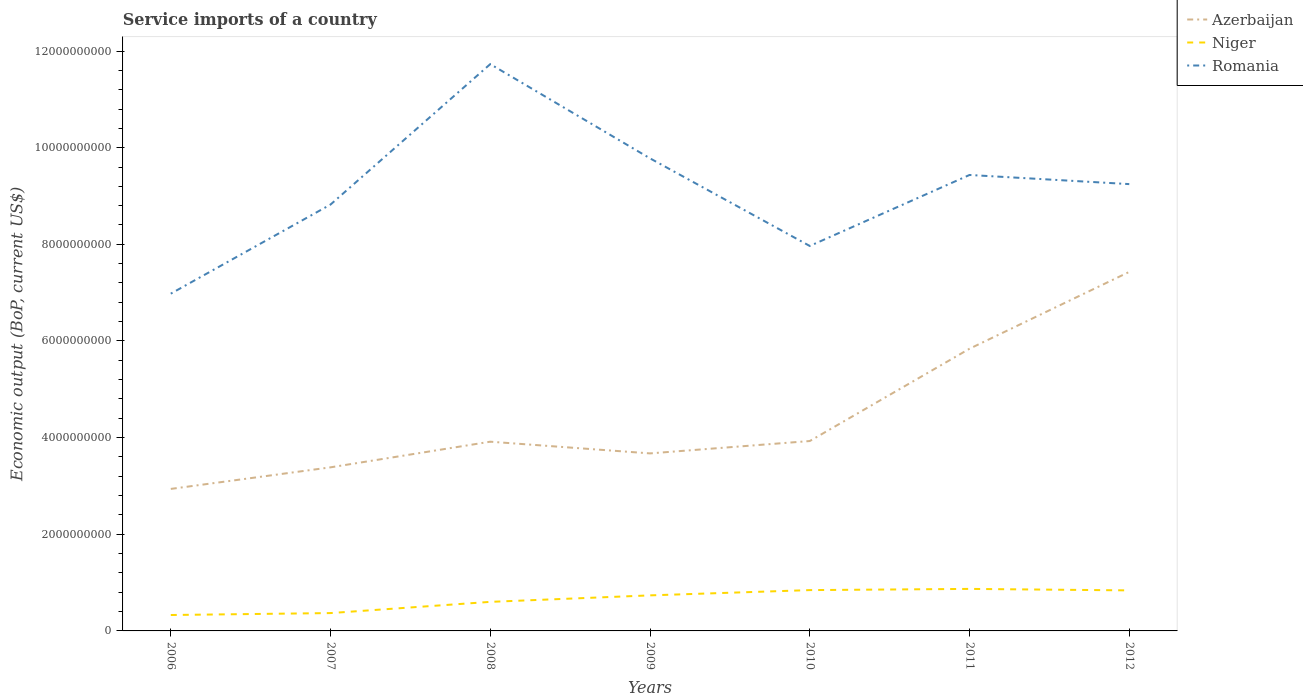How many different coloured lines are there?
Ensure brevity in your answer.  3. Is the number of lines equal to the number of legend labels?
Your answer should be very brief. Yes. Across all years, what is the maximum service imports in Romania?
Provide a short and direct response. 6.98e+09. What is the total service imports in Niger in the graph?
Offer a terse response. -1.34e+08. What is the difference between the highest and the second highest service imports in Niger?
Offer a very short reply. 5.40e+08. What is the difference between the highest and the lowest service imports in Azerbaijan?
Your answer should be very brief. 2. Is the service imports in Romania strictly greater than the service imports in Niger over the years?
Keep it short and to the point. No. How many lines are there?
Your answer should be very brief. 3. Are the values on the major ticks of Y-axis written in scientific E-notation?
Your response must be concise. No. How many legend labels are there?
Your answer should be very brief. 3. What is the title of the graph?
Offer a terse response. Service imports of a country. Does "Kenya" appear as one of the legend labels in the graph?
Your response must be concise. No. What is the label or title of the X-axis?
Provide a succinct answer. Years. What is the label or title of the Y-axis?
Your answer should be compact. Economic output (BoP, current US$). What is the Economic output (BoP, current US$) in Azerbaijan in 2006?
Your answer should be very brief. 2.94e+09. What is the Economic output (BoP, current US$) in Niger in 2006?
Make the answer very short. 3.29e+08. What is the Economic output (BoP, current US$) in Romania in 2006?
Your response must be concise. 6.98e+09. What is the Economic output (BoP, current US$) of Azerbaijan in 2007?
Offer a very short reply. 3.39e+09. What is the Economic output (BoP, current US$) of Niger in 2007?
Your response must be concise. 3.69e+08. What is the Economic output (BoP, current US$) of Romania in 2007?
Ensure brevity in your answer.  8.82e+09. What is the Economic output (BoP, current US$) in Azerbaijan in 2008?
Provide a short and direct response. 3.92e+09. What is the Economic output (BoP, current US$) of Niger in 2008?
Ensure brevity in your answer.  6.01e+08. What is the Economic output (BoP, current US$) of Romania in 2008?
Your response must be concise. 1.17e+1. What is the Economic output (BoP, current US$) in Azerbaijan in 2009?
Keep it short and to the point. 3.67e+09. What is the Economic output (BoP, current US$) of Niger in 2009?
Provide a short and direct response. 7.36e+08. What is the Economic output (BoP, current US$) in Romania in 2009?
Your answer should be compact. 9.78e+09. What is the Economic output (BoP, current US$) in Azerbaijan in 2010?
Ensure brevity in your answer.  3.93e+09. What is the Economic output (BoP, current US$) in Niger in 2010?
Give a very brief answer. 8.45e+08. What is the Economic output (BoP, current US$) of Romania in 2010?
Provide a succinct answer. 7.97e+09. What is the Economic output (BoP, current US$) of Azerbaijan in 2011?
Keep it short and to the point. 5.84e+09. What is the Economic output (BoP, current US$) of Niger in 2011?
Provide a succinct answer. 8.70e+08. What is the Economic output (BoP, current US$) of Romania in 2011?
Offer a very short reply. 9.44e+09. What is the Economic output (BoP, current US$) in Azerbaijan in 2012?
Provide a short and direct response. 7.43e+09. What is the Economic output (BoP, current US$) of Niger in 2012?
Keep it short and to the point. 8.39e+08. What is the Economic output (BoP, current US$) in Romania in 2012?
Give a very brief answer. 9.25e+09. Across all years, what is the maximum Economic output (BoP, current US$) in Azerbaijan?
Make the answer very short. 7.43e+09. Across all years, what is the maximum Economic output (BoP, current US$) in Niger?
Your answer should be very brief. 8.70e+08. Across all years, what is the maximum Economic output (BoP, current US$) of Romania?
Make the answer very short. 1.17e+1. Across all years, what is the minimum Economic output (BoP, current US$) in Azerbaijan?
Give a very brief answer. 2.94e+09. Across all years, what is the minimum Economic output (BoP, current US$) of Niger?
Ensure brevity in your answer.  3.29e+08. Across all years, what is the minimum Economic output (BoP, current US$) in Romania?
Your answer should be very brief. 6.98e+09. What is the total Economic output (BoP, current US$) of Azerbaijan in the graph?
Make the answer very short. 3.11e+1. What is the total Economic output (BoP, current US$) in Niger in the graph?
Offer a terse response. 4.59e+09. What is the total Economic output (BoP, current US$) of Romania in the graph?
Your answer should be very brief. 6.40e+1. What is the difference between the Economic output (BoP, current US$) in Azerbaijan in 2006 and that in 2007?
Keep it short and to the point. -4.47e+08. What is the difference between the Economic output (BoP, current US$) of Niger in 2006 and that in 2007?
Provide a succinct answer. -4.00e+07. What is the difference between the Economic output (BoP, current US$) in Romania in 2006 and that in 2007?
Your response must be concise. -1.84e+09. What is the difference between the Economic output (BoP, current US$) of Azerbaijan in 2006 and that in 2008?
Offer a very short reply. -9.77e+08. What is the difference between the Economic output (BoP, current US$) of Niger in 2006 and that in 2008?
Provide a short and direct response. -2.72e+08. What is the difference between the Economic output (BoP, current US$) in Romania in 2006 and that in 2008?
Your answer should be very brief. -4.75e+09. What is the difference between the Economic output (BoP, current US$) in Azerbaijan in 2006 and that in 2009?
Your response must be concise. -7.35e+08. What is the difference between the Economic output (BoP, current US$) of Niger in 2006 and that in 2009?
Keep it short and to the point. -4.06e+08. What is the difference between the Economic output (BoP, current US$) in Romania in 2006 and that in 2009?
Provide a succinct answer. -2.80e+09. What is the difference between the Economic output (BoP, current US$) in Azerbaijan in 2006 and that in 2010?
Give a very brief answer. -9.91e+08. What is the difference between the Economic output (BoP, current US$) in Niger in 2006 and that in 2010?
Provide a succinct answer. -5.15e+08. What is the difference between the Economic output (BoP, current US$) of Romania in 2006 and that in 2010?
Ensure brevity in your answer.  -9.87e+08. What is the difference between the Economic output (BoP, current US$) in Azerbaijan in 2006 and that in 2011?
Your answer should be compact. -2.90e+09. What is the difference between the Economic output (BoP, current US$) in Niger in 2006 and that in 2011?
Keep it short and to the point. -5.40e+08. What is the difference between the Economic output (BoP, current US$) in Romania in 2006 and that in 2011?
Provide a succinct answer. -2.46e+09. What is the difference between the Economic output (BoP, current US$) of Azerbaijan in 2006 and that in 2012?
Your answer should be very brief. -4.49e+09. What is the difference between the Economic output (BoP, current US$) of Niger in 2006 and that in 2012?
Offer a very short reply. -5.09e+08. What is the difference between the Economic output (BoP, current US$) in Romania in 2006 and that in 2012?
Offer a terse response. -2.27e+09. What is the difference between the Economic output (BoP, current US$) of Azerbaijan in 2007 and that in 2008?
Offer a terse response. -5.30e+08. What is the difference between the Economic output (BoP, current US$) in Niger in 2007 and that in 2008?
Make the answer very short. -2.32e+08. What is the difference between the Economic output (BoP, current US$) in Romania in 2007 and that in 2008?
Offer a terse response. -2.91e+09. What is the difference between the Economic output (BoP, current US$) in Azerbaijan in 2007 and that in 2009?
Make the answer very short. -2.88e+08. What is the difference between the Economic output (BoP, current US$) of Niger in 2007 and that in 2009?
Provide a short and direct response. -3.66e+08. What is the difference between the Economic output (BoP, current US$) in Romania in 2007 and that in 2009?
Keep it short and to the point. -9.56e+08. What is the difference between the Economic output (BoP, current US$) of Azerbaijan in 2007 and that in 2010?
Provide a succinct answer. -5.44e+08. What is the difference between the Economic output (BoP, current US$) in Niger in 2007 and that in 2010?
Provide a short and direct response. -4.75e+08. What is the difference between the Economic output (BoP, current US$) of Romania in 2007 and that in 2010?
Offer a terse response. 8.57e+08. What is the difference between the Economic output (BoP, current US$) of Azerbaijan in 2007 and that in 2011?
Your answer should be very brief. -2.45e+09. What is the difference between the Economic output (BoP, current US$) of Niger in 2007 and that in 2011?
Give a very brief answer. -5.00e+08. What is the difference between the Economic output (BoP, current US$) of Romania in 2007 and that in 2011?
Make the answer very short. -6.12e+08. What is the difference between the Economic output (BoP, current US$) of Azerbaijan in 2007 and that in 2012?
Give a very brief answer. -4.04e+09. What is the difference between the Economic output (BoP, current US$) in Niger in 2007 and that in 2012?
Provide a short and direct response. -4.69e+08. What is the difference between the Economic output (BoP, current US$) of Romania in 2007 and that in 2012?
Ensure brevity in your answer.  -4.23e+08. What is the difference between the Economic output (BoP, current US$) in Azerbaijan in 2008 and that in 2009?
Make the answer very short. 2.42e+08. What is the difference between the Economic output (BoP, current US$) in Niger in 2008 and that in 2009?
Provide a short and direct response. -1.34e+08. What is the difference between the Economic output (BoP, current US$) in Romania in 2008 and that in 2009?
Give a very brief answer. 1.95e+09. What is the difference between the Economic output (BoP, current US$) in Azerbaijan in 2008 and that in 2010?
Your answer should be compact. -1.38e+07. What is the difference between the Economic output (BoP, current US$) in Niger in 2008 and that in 2010?
Ensure brevity in your answer.  -2.43e+08. What is the difference between the Economic output (BoP, current US$) in Romania in 2008 and that in 2010?
Keep it short and to the point. 3.76e+09. What is the difference between the Economic output (BoP, current US$) in Azerbaijan in 2008 and that in 2011?
Ensure brevity in your answer.  -1.92e+09. What is the difference between the Economic output (BoP, current US$) of Niger in 2008 and that in 2011?
Keep it short and to the point. -2.68e+08. What is the difference between the Economic output (BoP, current US$) in Romania in 2008 and that in 2011?
Your answer should be very brief. 2.29e+09. What is the difference between the Economic output (BoP, current US$) in Azerbaijan in 2008 and that in 2012?
Your response must be concise. -3.51e+09. What is the difference between the Economic output (BoP, current US$) of Niger in 2008 and that in 2012?
Your response must be concise. -2.37e+08. What is the difference between the Economic output (BoP, current US$) in Romania in 2008 and that in 2012?
Offer a terse response. 2.48e+09. What is the difference between the Economic output (BoP, current US$) of Azerbaijan in 2009 and that in 2010?
Give a very brief answer. -2.56e+08. What is the difference between the Economic output (BoP, current US$) in Niger in 2009 and that in 2010?
Give a very brief answer. -1.09e+08. What is the difference between the Economic output (BoP, current US$) in Romania in 2009 and that in 2010?
Provide a succinct answer. 1.81e+09. What is the difference between the Economic output (BoP, current US$) of Azerbaijan in 2009 and that in 2011?
Make the answer very short. -2.17e+09. What is the difference between the Economic output (BoP, current US$) in Niger in 2009 and that in 2011?
Make the answer very short. -1.34e+08. What is the difference between the Economic output (BoP, current US$) in Romania in 2009 and that in 2011?
Ensure brevity in your answer.  3.44e+08. What is the difference between the Economic output (BoP, current US$) of Azerbaijan in 2009 and that in 2012?
Offer a terse response. -3.76e+09. What is the difference between the Economic output (BoP, current US$) of Niger in 2009 and that in 2012?
Provide a succinct answer. -1.03e+08. What is the difference between the Economic output (BoP, current US$) of Romania in 2009 and that in 2012?
Your answer should be compact. 5.33e+08. What is the difference between the Economic output (BoP, current US$) of Azerbaijan in 2010 and that in 2011?
Keep it short and to the point. -1.91e+09. What is the difference between the Economic output (BoP, current US$) in Niger in 2010 and that in 2011?
Offer a very short reply. -2.49e+07. What is the difference between the Economic output (BoP, current US$) in Romania in 2010 and that in 2011?
Provide a succinct answer. -1.47e+09. What is the difference between the Economic output (BoP, current US$) in Azerbaijan in 2010 and that in 2012?
Provide a short and direct response. -3.50e+09. What is the difference between the Economic output (BoP, current US$) in Niger in 2010 and that in 2012?
Make the answer very short. 6.03e+06. What is the difference between the Economic output (BoP, current US$) in Romania in 2010 and that in 2012?
Make the answer very short. -1.28e+09. What is the difference between the Economic output (BoP, current US$) of Azerbaijan in 2011 and that in 2012?
Keep it short and to the point. -1.59e+09. What is the difference between the Economic output (BoP, current US$) in Niger in 2011 and that in 2012?
Offer a very short reply. 3.09e+07. What is the difference between the Economic output (BoP, current US$) in Romania in 2011 and that in 2012?
Offer a terse response. 1.89e+08. What is the difference between the Economic output (BoP, current US$) in Azerbaijan in 2006 and the Economic output (BoP, current US$) in Niger in 2007?
Your response must be concise. 2.57e+09. What is the difference between the Economic output (BoP, current US$) in Azerbaijan in 2006 and the Economic output (BoP, current US$) in Romania in 2007?
Ensure brevity in your answer.  -5.88e+09. What is the difference between the Economic output (BoP, current US$) in Niger in 2006 and the Economic output (BoP, current US$) in Romania in 2007?
Offer a very short reply. -8.49e+09. What is the difference between the Economic output (BoP, current US$) in Azerbaijan in 2006 and the Economic output (BoP, current US$) in Niger in 2008?
Your response must be concise. 2.34e+09. What is the difference between the Economic output (BoP, current US$) in Azerbaijan in 2006 and the Economic output (BoP, current US$) in Romania in 2008?
Your answer should be very brief. -8.79e+09. What is the difference between the Economic output (BoP, current US$) in Niger in 2006 and the Economic output (BoP, current US$) in Romania in 2008?
Keep it short and to the point. -1.14e+1. What is the difference between the Economic output (BoP, current US$) in Azerbaijan in 2006 and the Economic output (BoP, current US$) in Niger in 2009?
Provide a succinct answer. 2.20e+09. What is the difference between the Economic output (BoP, current US$) of Azerbaijan in 2006 and the Economic output (BoP, current US$) of Romania in 2009?
Your response must be concise. -6.84e+09. What is the difference between the Economic output (BoP, current US$) in Niger in 2006 and the Economic output (BoP, current US$) in Romania in 2009?
Your response must be concise. -9.45e+09. What is the difference between the Economic output (BoP, current US$) in Azerbaijan in 2006 and the Economic output (BoP, current US$) in Niger in 2010?
Make the answer very short. 2.09e+09. What is the difference between the Economic output (BoP, current US$) of Azerbaijan in 2006 and the Economic output (BoP, current US$) of Romania in 2010?
Your answer should be compact. -5.03e+09. What is the difference between the Economic output (BoP, current US$) of Niger in 2006 and the Economic output (BoP, current US$) of Romania in 2010?
Your response must be concise. -7.64e+09. What is the difference between the Economic output (BoP, current US$) of Azerbaijan in 2006 and the Economic output (BoP, current US$) of Niger in 2011?
Keep it short and to the point. 2.07e+09. What is the difference between the Economic output (BoP, current US$) in Azerbaijan in 2006 and the Economic output (BoP, current US$) in Romania in 2011?
Keep it short and to the point. -6.50e+09. What is the difference between the Economic output (BoP, current US$) of Niger in 2006 and the Economic output (BoP, current US$) of Romania in 2011?
Keep it short and to the point. -9.11e+09. What is the difference between the Economic output (BoP, current US$) in Azerbaijan in 2006 and the Economic output (BoP, current US$) in Niger in 2012?
Make the answer very short. 2.10e+09. What is the difference between the Economic output (BoP, current US$) in Azerbaijan in 2006 and the Economic output (BoP, current US$) in Romania in 2012?
Offer a terse response. -6.31e+09. What is the difference between the Economic output (BoP, current US$) of Niger in 2006 and the Economic output (BoP, current US$) of Romania in 2012?
Provide a short and direct response. -8.92e+09. What is the difference between the Economic output (BoP, current US$) in Azerbaijan in 2007 and the Economic output (BoP, current US$) in Niger in 2008?
Your response must be concise. 2.78e+09. What is the difference between the Economic output (BoP, current US$) in Azerbaijan in 2007 and the Economic output (BoP, current US$) in Romania in 2008?
Your answer should be compact. -8.34e+09. What is the difference between the Economic output (BoP, current US$) in Niger in 2007 and the Economic output (BoP, current US$) in Romania in 2008?
Make the answer very short. -1.14e+1. What is the difference between the Economic output (BoP, current US$) in Azerbaijan in 2007 and the Economic output (BoP, current US$) in Niger in 2009?
Give a very brief answer. 2.65e+09. What is the difference between the Economic output (BoP, current US$) of Azerbaijan in 2007 and the Economic output (BoP, current US$) of Romania in 2009?
Keep it short and to the point. -6.39e+09. What is the difference between the Economic output (BoP, current US$) of Niger in 2007 and the Economic output (BoP, current US$) of Romania in 2009?
Your answer should be compact. -9.41e+09. What is the difference between the Economic output (BoP, current US$) of Azerbaijan in 2007 and the Economic output (BoP, current US$) of Niger in 2010?
Give a very brief answer. 2.54e+09. What is the difference between the Economic output (BoP, current US$) of Azerbaijan in 2007 and the Economic output (BoP, current US$) of Romania in 2010?
Offer a very short reply. -4.58e+09. What is the difference between the Economic output (BoP, current US$) of Niger in 2007 and the Economic output (BoP, current US$) of Romania in 2010?
Offer a very short reply. -7.60e+09. What is the difference between the Economic output (BoP, current US$) of Azerbaijan in 2007 and the Economic output (BoP, current US$) of Niger in 2011?
Your answer should be very brief. 2.52e+09. What is the difference between the Economic output (BoP, current US$) of Azerbaijan in 2007 and the Economic output (BoP, current US$) of Romania in 2011?
Ensure brevity in your answer.  -6.05e+09. What is the difference between the Economic output (BoP, current US$) of Niger in 2007 and the Economic output (BoP, current US$) of Romania in 2011?
Your answer should be very brief. -9.07e+09. What is the difference between the Economic output (BoP, current US$) in Azerbaijan in 2007 and the Economic output (BoP, current US$) in Niger in 2012?
Give a very brief answer. 2.55e+09. What is the difference between the Economic output (BoP, current US$) in Azerbaijan in 2007 and the Economic output (BoP, current US$) in Romania in 2012?
Ensure brevity in your answer.  -5.86e+09. What is the difference between the Economic output (BoP, current US$) of Niger in 2007 and the Economic output (BoP, current US$) of Romania in 2012?
Your answer should be very brief. -8.88e+09. What is the difference between the Economic output (BoP, current US$) in Azerbaijan in 2008 and the Economic output (BoP, current US$) in Niger in 2009?
Your answer should be very brief. 3.18e+09. What is the difference between the Economic output (BoP, current US$) of Azerbaijan in 2008 and the Economic output (BoP, current US$) of Romania in 2009?
Offer a very short reply. -5.86e+09. What is the difference between the Economic output (BoP, current US$) in Niger in 2008 and the Economic output (BoP, current US$) in Romania in 2009?
Your response must be concise. -9.18e+09. What is the difference between the Economic output (BoP, current US$) in Azerbaijan in 2008 and the Economic output (BoP, current US$) in Niger in 2010?
Keep it short and to the point. 3.07e+09. What is the difference between the Economic output (BoP, current US$) of Azerbaijan in 2008 and the Economic output (BoP, current US$) of Romania in 2010?
Your answer should be compact. -4.05e+09. What is the difference between the Economic output (BoP, current US$) in Niger in 2008 and the Economic output (BoP, current US$) in Romania in 2010?
Offer a terse response. -7.36e+09. What is the difference between the Economic output (BoP, current US$) in Azerbaijan in 2008 and the Economic output (BoP, current US$) in Niger in 2011?
Provide a short and direct response. 3.05e+09. What is the difference between the Economic output (BoP, current US$) of Azerbaijan in 2008 and the Economic output (BoP, current US$) of Romania in 2011?
Make the answer very short. -5.52e+09. What is the difference between the Economic output (BoP, current US$) of Niger in 2008 and the Economic output (BoP, current US$) of Romania in 2011?
Offer a very short reply. -8.83e+09. What is the difference between the Economic output (BoP, current US$) of Azerbaijan in 2008 and the Economic output (BoP, current US$) of Niger in 2012?
Keep it short and to the point. 3.08e+09. What is the difference between the Economic output (BoP, current US$) in Azerbaijan in 2008 and the Economic output (BoP, current US$) in Romania in 2012?
Offer a very short reply. -5.33e+09. What is the difference between the Economic output (BoP, current US$) in Niger in 2008 and the Economic output (BoP, current US$) in Romania in 2012?
Make the answer very short. -8.64e+09. What is the difference between the Economic output (BoP, current US$) in Azerbaijan in 2009 and the Economic output (BoP, current US$) in Niger in 2010?
Your answer should be very brief. 2.83e+09. What is the difference between the Economic output (BoP, current US$) in Azerbaijan in 2009 and the Economic output (BoP, current US$) in Romania in 2010?
Keep it short and to the point. -4.29e+09. What is the difference between the Economic output (BoP, current US$) in Niger in 2009 and the Economic output (BoP, current US$) in Romania in 2010?
Provide a succinct answer. -7.23e+09. What is the difference between the Economic output (BoP, current US$) of Azerbaijan in 2009 and the Economic output (BoP, current US$) of Niger in 2011?
Offer a very short reply. 2.80e+09. What is the difference between the Economic output (BoP, current US$) in Azerbaijan in 2009 and the Economic output (BoP, current US$) in Romania in 2011?
Offer a terse response. -5.76e+09. What is the difference between the Economic output (BoP, current US$) of Niger in 2009 and the Economic output (BoP, current US$) of Romania in 2011?
Give a very brief answer. -8.70e+09. What is the difference between the Economic output (BoP, current US$) of Azerbaijan in 2009 and the Economic output (BoP, current US$) of Niger in 2012?
Offer a very short reply. 2.83e+09. What is the difference between the Economic output (BoP, current US$) of Azerbaijan in 2009 and the Economic output (BoP, current US$) of Romania in 2012?
Offer a very short reply. -5.57e+09. What is the difference between the Economic output (BoP, current US$) in Niger in 2009 and the Economic output (BoP, current US$) in Romania in 2012?
Offer a terse response. -8.51e+09. What is the difference between the Economic output (BoP, current US$) in Azerbaijan in 2010 and the Economic output (BoP, current US$) in Niger in 2011?
Offer a very short reply. 3.06e+09. What is the difference between the Economic output (BoP, current US$) in Azerbaijan in 2010 and the Economic output (BoP, current US$) in Romania in 2011?
Give a very brief answer. -5.51e+09. What is the difference between the Economic output (BoP, current US$) of Niger in 2010 and the Economic output (BoP, current US$) of Romania in 2011?
Your response must be concise. -8.59e+09. What is the difference between the Economic output (BoP, current US$) of Azerbaijan in 2010 and the Economic output (BoP, current US$) of Niger in 2012?
Provide a succinct answer. 3.09e+09. What is the difference between the Economic output (BoP, current US$) in Azerbaijan in 2010 and the Economic output (BoP, current US$) in Romania in 2012?
Your response must be concise. -5.32e+09. What is the difference between the Economic output (BoP, current US$) in Niger in 2010 and the Economic output (BoP, current US$) in Romania in 2012?
Offer a very short reply. -8.40e+09. What is the difference between the Economic output (BoP, current US$) in Azerbaijan in 2011 and the Economic output (BoP, current US$) in Niger in 2012?
Your response must be concise. 5.00e+09. What is the difference between the Economic output (BoP, current US$) in Azerbaijan in 2011 and the Economic output (BoP, current US$) in Romania in 2012?
Ensure brevity in your answer.  -3.41e+09. What is the difference between the Economic output (BoP, current US$) of Niger in 2011 and the Economic output (BoP, current US$) of Romania in 2012?
Offer a very short reply. -8.38e+09. What is the average Economic output (BoP, current US$) of Azerbaijan per year?
Your response must be concise. 4.44e+09. What is the average Economic output (BoP, current US$) of Niger per year?
Your response must be concise. 6.56e+08. What is the average Economic output (BoP, current US$) of Romania per year?
Your answer should be very brief. 9.14e+09. In the year 2006, what is the difference between the Economic output (BoP, current US$) in Azerbaijan and Economic output (BoP, current US$) in Niger?
Give a very brief answer. 2.61e+09. In the year 2006, what is the difference between the Economic output (BoP, current US$) of Azerbaijan and Economic output (BoP, current US$) of Romania?
Your response must be concise. -4.04e+09. In the year 2006, what is the difference between the Economic output (BoP, current US$) in Niger and Economic output (BoP, current US$) in Romania?
Your answer should be compact. -6.65e+09. In the year 2007, what is the difference between the Economic output (BoP, current US$) of Azerbaijan and Economic output (BoP, current US$) of Niger?
Your answer should be compact. 3.02e+09. In the year 2007, what is the difference between the Economic output (BoP, current US$) in Azerbaijan and Economic output (BoP, current US$) in Romania?
Offer a terse response. -5.44e+09. In the year 2007, what is the difference between the Economic output (BoP, current US$) of Niger and Economic output (BoP, current US$) of Romania?
Provide a succinct answer. -8.45e+09. In the year 2008, what is the difference between the Economic output (BoP, current US$) in Azerbaijan and Economic output (BoP, current US$) in Niger?
Your answer should be very brief. 3.31e+09. In the year 2008, what is the difference between the Economic output (BoP, current US$) in Azerbaijan and Economic output (BoP, current US$) in Romania?
Offer a very short reply. -7.81e+09. In the year 2008, what is the difference between the Economic output (BoP, current US$) of Niger and Economic output (BoP, current US$) of Romania?
Give a very brief answer. -1.11e+1. In the year 2009, what is the difference between the Economic output (BoP, current US$) of Azerbaijan and Economic output (BoP, current US$) of Niger?
Provide a short and direct response. 2.94e+09. In the year 2009, what is the difference between the Economic output (BoP, current US$) of Azerbaijan and Economic output (BoP, current US$) of Romania?
Your response must be concise. -6.11e+09. In the year 2009, what is the difference between the Economic output (BoP, current US$) in Niger and Economic output (BoP, current US$) in Romania?
Ensure brevity in your answer.  -9.04e+09. In the year 2010, what is the difference between the Economic output (BoP, current US$) in Azerbaijan and Economic output (BoP, current US$) in Niger?
Your answer should be compact. 3.08e+09. In the year 2010, what is the difference between the Economic output (BoP, current US$) of Azerbaijan and Economic output (BoP, current US$) of Romania?
Keep it short and to the point. -4.04e+09. In the year 2010, what is the difference between the Economic output (BoP, current US$) of Niger and Economic output (BoP, current US$) of Romania?
Offer a terse response. -7.12e+09. In the year 2011, what is the difference between the Economic output (BoP, current US$) of Azerbaijan and Economic output (BoP, current US$) of Niger?
Keep it short and to the point. 4.97e+09. In the year 2011, what is the difference between the Economic output (BoP, current US$) in Azerbaijan and Economic output (BoP, current US$) in Romania?
Give a very brief answer. -3.60e+09. In the year 2011, what is the difference between the Economic output (BoP, current US$) in Niger and Economic output (BoP, current US$) in Romania?
Your response must be concise. -8.57e+09. In the year 2012, what is the difference between the Economic output (BoP, current US$) in Azerbaijan and Economic output (BoP, current US$) in Niger?
Give a very brief answer. 6.59e+09. In the year 2012, what is the difference between the Economic output (BoP, current US$) in Azerbaijan and Economic output (BoP, current US$) in Romania?
Make the answer very short. -1.82e+09. In the year 2012, what is the difference between the Economic output (BoP, current US$) of Niger and Economic output (BoP, current US$) of Romania?
Provide a short and direct response. -8.41e+09. What is the ratio of the Economic output (BoP, current US$) of Azerbaijan in 2006 to that in 2007?
Your answer should be compact. 0.87. What is the ratio of the Economic output (BoP, current US$) in Niger in 2006 to that in 2007?
Give a very brief answer. 0.89. What is the ratio of the Economic output (BoP, current US$) of Romania in 2006 to that in 2007?
Offer a terse response. 0.79. What is the ratio of the Economic output (BoP, current US$) in Azerbaijan in 2006 to that in 2008?
Your answer should be very brief. 0.75. What is the ratio of the Economic output (BoP, current US$) of Niger in 2006 to that in 2008?
Provide a succinct answer. 0.55. What is the ratio of the Economic output (BoP, current US$) of Romania in 2006 to that in 2008?
Offer a terse response. 0.59. What is the ratio of the Economic output (BoP, current US$) of Niger in 2006 to that in 2009?
Offer a very short reply. 0.45. What is the ratio of the Economic output (BoP, current US$) in Romania in 2006 to that in 2009?
Your answer should be compact. 0.71. What is the ratio of the Economic output (BoP, current US$) of Azerbaijan in 2006 to that in 2010?
Offer a terse response. 0.75. What is the ratio of the Economic output (BoP, current US$) in Niger in 2006 to that in 2010?
Keep it short and to the point. 0.39. What is the ratio of the Economic output (BoP, current US$) in Romania in 2006 to that in 2010?
Provide a succinct answer. 0.88. What is the ratio of the Economic output (BoP, current US$) of Azerbaijan in 2006 to that in 2011?
Keep it short and to the point. 0.5. What is the ratio of the Economic output (BoP, current US$) of Niger in 2006 to that in 2011?
Keep it short and to the point. 0.38. What is the ratio of the Economic output (BoP, current US$) in Romania in 2006 to that in 2011?
Provide a short and direct response. 0.74. What is the ratio of the Economic output (BoP, current US$) of Azerbaijan in 2006 to that in 2012?
Offer a terse response. 0.4. What is the ratio of the Economic output (BoP, current US$) of Niger in 2006 to that in 2012?
Give a very brief answer. 0.39. What is the ratio of the Economic output (BoP, current US$) in Romania in 2006 to that in 2012?
Your answer should be very brief. 0.75. What is the ratio of the Economic output (BoP, current US$) in Azerbaijan in 2007 to that in 2008?
Offer a terse response. 0.86. What is the ratio of the Economic output (BoP, current US$) of Niger in 2007 to that in 2008?
Provide a succinct answer. 0.61. What is the ratio of the Economic output (BoP, current US$) of Romania in 2007 to that in 2008?
Keep it short and to the point. 0.75. What is the ratio of the Economic output (BoP, current US$) in Azerbaijan in 2007 to that in 2009?
Your answer should be very brief. 0.92. What is the ratio of the Economic output (BoP, current US$) in Niger in 2007 to that in 2009?
Your answer should be very brief. 0.5. What is the ratio of the Economic output (BoP, current US$) in Romania in 2007 to that in 2009?
Provide a succinct answer. 0.9. What is the ratio of the Economic output (BoP, current US$) in Azerbaijan in 2007 to that in 2010?
Provide a short and direct response. 0.86. What is the ratio of the Economic output (BoP, current US$) of Niger in 2007 to that in 2010?
Keep it short and to the point. 0.44. What is the ratio of the Economic output (BoP, current US$) of Romania in 2007 to that in 2010?
Make the answer very short. 1.11. What is the ratio of the Economic output (BoP, current US$) of Azerbaijan in 2007 to that in 2011?
Provide a succinct answer. 0.58. What is the ratio of the Economic output (BoP, current US$) in Niger in 2007 to that in 2011?
Make the answer very short. 0.42. What is the ratio of the Economic output (BoP, current US$) of Romania in 2007 to that in 2011?
Give a very brief answer. 0.94. What is the ratio of the Economic output (BoP, current US$) in Azerbaijan in 2007 to that in 2012?
Offer a terse response. 0.46. What is the ratio of the Economic output (BoP, current US$) in Niger in 2007 to that in 2012?
Make the answer very short. 0.44. What is the ratio of the Economic output (BoP, current US$) in Romania in 2007 to that in 2012?
Give a very brief answer. 0.95. What is the ratio of the Economic output (BoP, current US$) in Azerbaijan in 2008 to that in 2009?
Give a very brief answer. 1.07. What is the ratio of the Economic output (BoP, current US$) in Niger in 2008 to that in 2009?
Offer a terse response. 0.82. What is the ratio of the Economic output (BoP, current US$) in Romania in 2008 to that in 2009?
Your answer should be very brief. 1.2. What is the ratio of the Economic output (BoP, current US$) in Niger in 2008 to that in 2010?
Make the answer very short. 0.71. What is the ratio of the Economic output (BoP, current US$) in Romania in 2008 to that in 2010?
Give a very brief answer. 1.47. What is the ratio of the Economic output (BoP, current US$) of Azerbaijan in 2008 to that in 2011?
Your response must be concise. 0.67. What is the ratio of the Economic output (BoP, current US$) in Niger in 2008 to that in 2011?
Provide a succinct answer. 0.69. What is the ratio of the Economic output (BoP, current US$) of Romania in 2008 to that in 2011?
Offer a terse response. 1.24. What is the ratio of the Economic output (BoP, current US$) of Azerbaijan in 2008 to that in 2012?
Your answer should be very brief. 0.53. What is the ratio of the Economic output (BoP, current US$) in Niger in 2008 to that in 2012?
Ensure brevity in your answer.  0.72. What is the ratio of the Economic output (BoP, current US$) of Romania in 2008 to that in 2012?
Your answer should be very brief. 1.27. What is the ratio of the Economic output (BoP, current US$) of Azerbaijan in 2009 to that in 2010?
Offer a very short reply. 0.93. What is the ratio of the Economic output (BoP, current US$) of Niger in 2009 to that in 2010?
Provide a short and direct response. 0.87. What is the ratio of the Economic output (BoP, current US$) of Romania in 2009 to that in 2010?
Your answer should be compact. 1.23. What is the ratio of the Economic output (BoP, current US$) of Azerbaijan in 2009 to that in 2011?
Make the answer very short. 0.63. What is the ratio of the Economic output (BoP, current US$) in Niger in 2009 to that in 2011?
Provide a short and direct response. 0.85. What is the ratio of the Economic output (BoP, current US$) of Romania in 2009 to that in 2011?
Provide a succinct answer. 1.04. What is the ratio of the Economic output (BoP, current US$) in Azerbaijan in 2009 to that in 2012?
Offer a very short reply. 0.49. What is the ratio of the Economic output (BoP, current US$) in Niger in 2009 to that in 2012?
Keep it short and to the point. 0.88. What is the ratio of the Economic output (BoP, current US$) in Romania in 2009 to that in 2012?
Give a very brief answer. 1.06. What is the ratio of the Economic output (BoP, current US$) in Azerbaijan in 2010 to that in 2011?
Offer a very short reply. 0.67. What is the ratio of the Economic output (BoP, current US$) of Niger in 2010 to that in 2011?
Provide a succinct answer. 0.97. What is the ratio of the Economic output (BoP, current US$) of Romania in 2010 to that in 2011?
Your response must be concise. 0.84. What is the ratio of the Economic output (BoP, current US$) in Azerbaijan in 2010 to that in 2012?
Make the answer very short. 0.53. What is the ratio of the Economic output (BoP, current US$) in Romania in 2010 to that in 2012?
Provide a short and direct response. 0.86. What is the ratio of the Economic output (BoP, current US$) of Azerbaijan in 2011 to that in 2012?
Your answer should be compact. 0.79. What is the ratio of the Economic output (BoP, current US$) of Niger in 2011 to that in 2012?
Offer a very short reply. 1.04. What is the ratio of the Economic output (BoP, current US$) in Romania in 2011 to that in 2012?
Keep it short and to the point. 1.02. What is the difference between the highest and the second highest Economic output (BoP, current US$) in Azerbaijan?
Provide a short and direct response. 1.59e+09. What is the difference between the highest and the second highest Economic output (BoP, current US$) of Niger?
Offer a very short reply. 2.49e+07. What is the difference between the highest and the second highest Economic output (BoP, current US$) of Romania?
Ensure brevity in your answer.  1.95e+09. What is the difference between the highest and the lowest Economic output (BoP, current US$) in Azerbaijan?
Your answer should be very brief. 4.49e+09. What is the difference between the highest and the lowest Economic output (BoP, current US$) in Niger?
Make the answer very short. 5.40e+08. What is the difference between the highest and the lowest Economic output (BoP, current US$) in Romania?
Offer a terse response. 4.75e+09. 